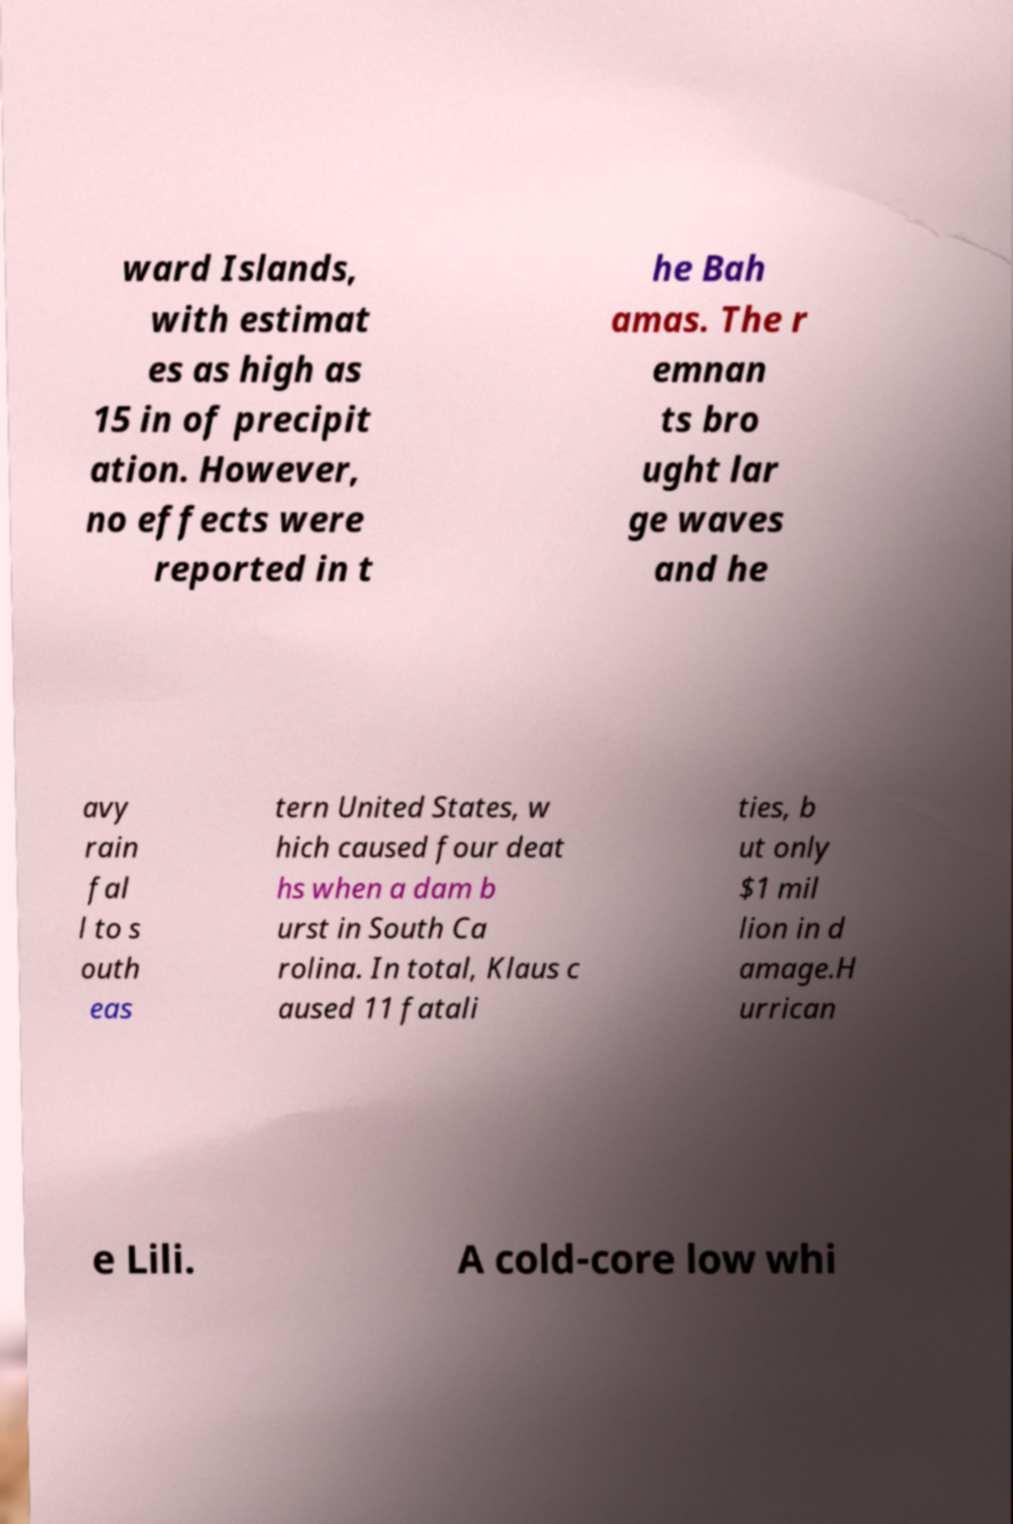Could you assist in decoding the text presented in this image and type it out clearly? ward Islands, with estimat es as high as 15 in of precipit ation. However, no effects were reported in t he Bah amas. The r emnan ts bro ught lar ge waves and he avy rain fal l to s outh eas tern United States, w hich caused four deat hs when a dam b urst in South Ca rolina. In total, Klaus c aused 11 fatali ties, b ut only $1 mil lion in d amage.H urrican e Lili. A cold-core low whi 